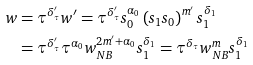Convert formula to latex. <formula><loc_0><loc_0><loc_500><loc_500>w & = \tau ^ { \delta _ { \tau } ^ { \prime } } w ^ { \prime } = \tau ^ { \delta _ { \tau } ^ { \prime } } s _ { 0 } ^ { \alpha _ { 0 } } \left ( s _ { 1 } s _ { 0 } \right ) ^ { m ^ { \prime } } s _ { 1 } ^ { \delta _ { 1 } } \\ & = \tau ^ { \delta _ { \tau } ^ { \prime } } \tau ^ { \alpha _ { 0 } } w _ { N B } ^ { 2 m ^ { \prime } + \alpha _ { 0 } } s _ { 1 } ^ { \delta _ { 1 } } = \tau ^ { \delta _ { \tau } } w _ { N B } ^ { m } s _ { 1 } ^ { \delta _ { 1 } }</formula> 